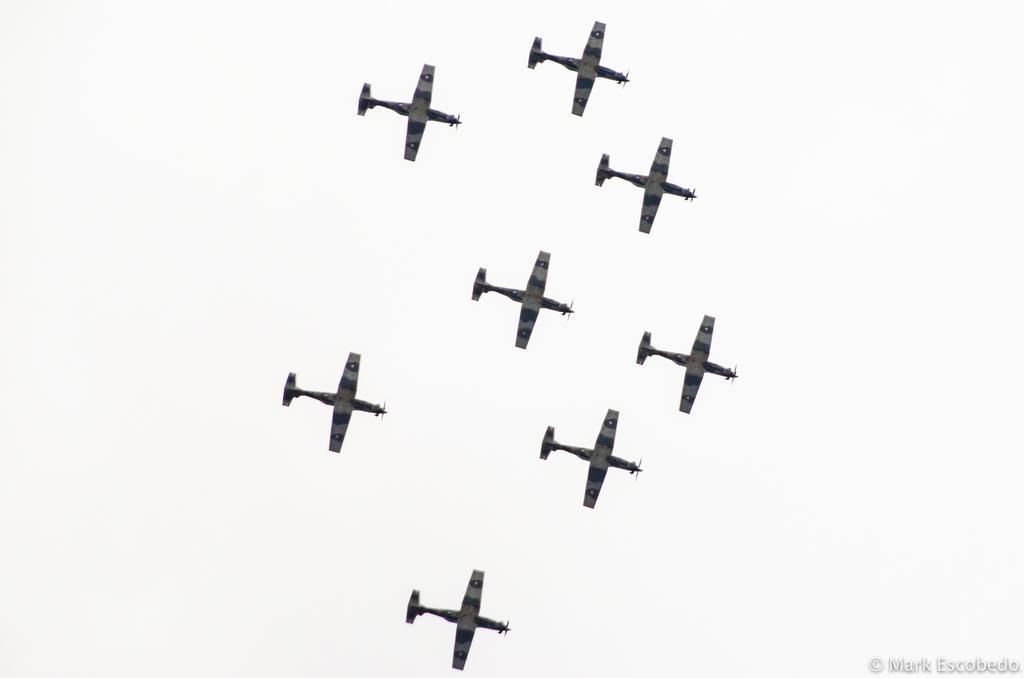Describe this image in one or two sentences. In this picture I can see few aeroplanes in the sky and a watermark at the bottom right corner. 